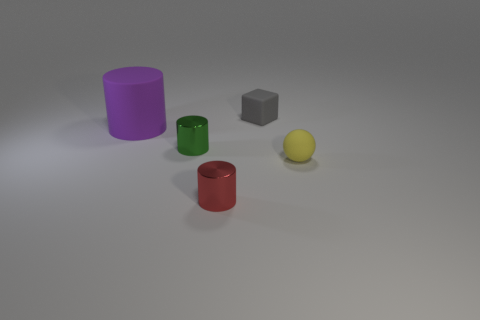Add 2 big matte things. How many objects exist? 7 Subtract all big purple cylinders. How many cylinders are left? 2 Subtract 1 cylinders. How many cylinders are left? 2 Subtract all blocks. How many objects are left? 4 Subtract all yellow cylinders. Subtract all green cubes. How many cylinders are left? 3 Subtract all small green metal things. Subtract all tiny cubes. How many objects are left? 3 Add 4 tiny metallic cylinders. How many tiny metallic cylinders are left? 6 Add 5 large purple rubber objects. How many large purple rubber objects exist? 6 Subtract 0 cyan blocks. How many objects are left? 5 